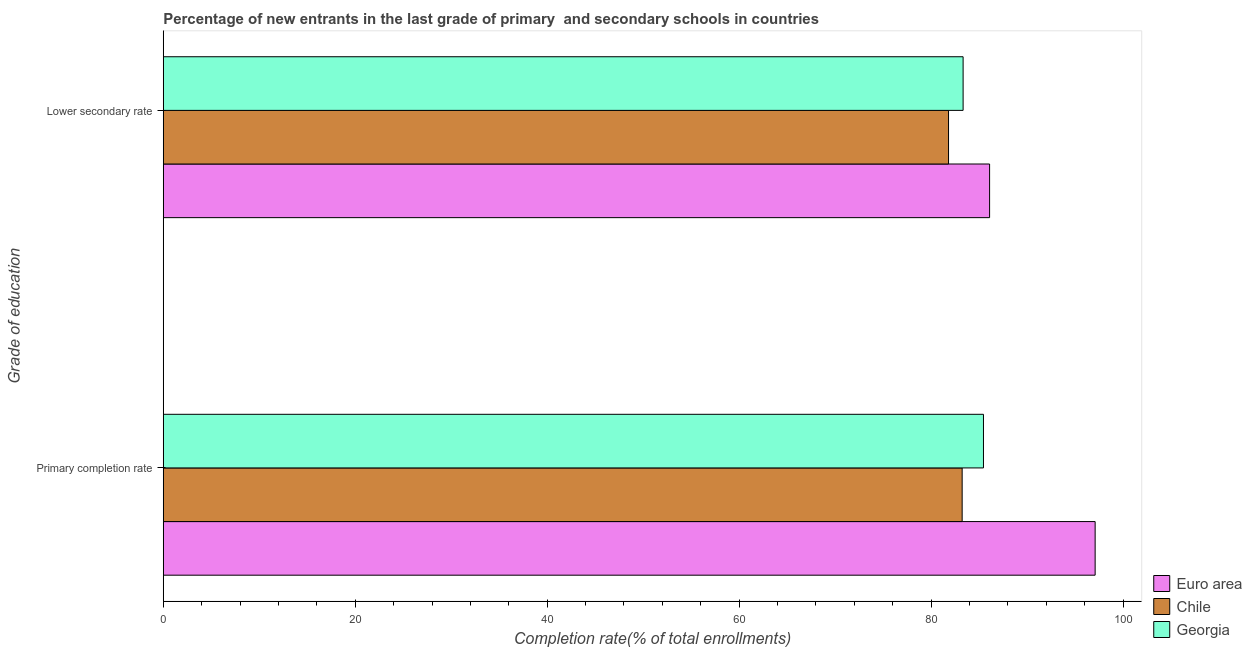How many different coloured bars are there?
Provide a succinct answer. 3. Are the number of bars on each tick of the Y-axis equal?
Provide a succinct answer. Yes. What is the label of the 2nd group of bars from the top?
Offer a very short reply. Primary completion rate. What is the completion rate in secondary schools in Euro area?
Offer a very short reply. 86.09. Across all countries, what is the maximum completion rate in secondary schools?
Your answer should be very brief. 86.09. Across all countries, what is the minimum completion rate in secondary schools?
Make the answer very short. 81.81. In which country was the completion rate in primary schools maximum?
Your answer should be compact. Euro area. In which country was the completion rate in primary schools minimum?
Give a very brief answer. Chile. What is the total completion rate in primary schools in the graph?
Your answer should be compact. 265.78. What is the difference between the completion rate in primary schools in Euro area and that in Georgia?
Provide a short and direct response. 11.63. What is the difference between the completion rate in secondary schools in Georgia and the completion rate in primary schools in Euro area?
Make the answer very short. -13.76. What is the average completion rate in secondary schools per country?
Your response must be concise. 83.75. What is the difference between the completion rate in primary schools and completion rate in secondary schools in Euro area?
Keep it short and to the point. 11. What is the ratio of the completion rate in secondary schools in Georgia to that in Euro area?
Give a very brief answer. 0.97. Is the completion rate in secondary schools in Georgia less than that in Chile?
Give a very brief answer. No. What does the 1st bar from the bottom in Primary completion rate represents?
Offer a very short reply. Euro area. Are all the bars in the graph horizontal?
Ensure brevity in your answer.  Yes. How many countries are there in the graph?
Make the answer very short. 3. Does the graph contain any zero values?
Make the answer very short. No. Does the graph contain grids?
Provide a short and direct response. No. How are the legend labels stacked?
Ensure brevity in your answer.  Vertical. What is the title of the graph?
Ensure brevity in your answer.  Percentage of new entrants in the last grade of primary  and secondary schools in countries. Does "High income: OECD" appear as one of the legend labels in the graph?
Make the answer very short. No. What is the label or title of the X-axis?
Your response must be concise. Completion rate(% of total enrollments). What is the label or title of the Y-axis?
Your answer should be compact. Grade of education. What is the Completion rate(% of total enrollments) of Euro area in Primary completion rate?
Provide a succinct answer. 97.09. What is the Completion rate(% of total enrollments) of Chile in Primary completion rate?
Provide a short and direct response. 83.23. What is the Completion rate(% of total enrollments) of Georgia in Primary completion rate?
Your answer should be very brief. 85.46. What is the Completion rate(% of total enrollments) of Euro area in Lower secondary rate?
Your response must be concise. 86.09. What is the Completion rate(% of total enrollments) in Chile in Lower secondary rate?
Ensure brevity in your answer.  81.81. What is the Completion rate(% of total enrollments) of Georgia in Lower secondary rate?
Your answer should be compact. 83.33. Across all Grade of education, what is the maximum Completion rate(% of total enrollments) of Euro area?
Provide a succinct answer. 97.09. Across all Grade of education, what is the maximum Completion rate(% of total enrollments) of Chile?
Offer a very short reply. 83.23. Across all Grade of education, what is the maximum Completion rate(% of total enrollments) in Georgia?
Your response must be concise. 85.46. Across all Grade of education, what is the minimum Completion rate(% of total enrollments) in Euro area?
Provide a short and direct response. 86.09. Across all Grade of education, what is the minimum Completion rate(% of total enrollments) in Chile?
Your response must be concise. 81.81. Across all Grade of education, what is the minimum Completion rate(% of total enrollments) of Georgia?
Provide a short and direct response. 83.33. What is the total Completion rate(% of total enrollments) of Euro area in the graph?
Make the answer very short. 183.18. What is the total Completion rate(% of total enrollments) in Chile in the graph?
Provide a succinct answer. 165.05. What is the total Completion rate(% of total enrollments) in Georgia in the graph?
Provide a succinct answer. 168.79. What is the difference between the Completion rate(% of total enrollments) of Euro area in Primary completion rate and that in Lower secondary rate?
Your answer should be compact. 11. What is the difference between the Completion rate(% of total enrollments) of Chile in Primary completion rate and that in Lower secondary rate?
Your response must be concise. 1.42. What is the difference between the Completion rate(% of total enrollments) of Georgia in Primary completion rate and that in Lower secondary rate?
Keep it short and to the point. 2.12. What is the difference between the Completion rate(% of total enrollments) in Euro area in Primary completion rate and the Completion rate(% of total enrollments) in Chile in Lower secondary rate?
Your response must be concise. 15.27. What is the difference between the Completion rate(% of total enrollments) in Euro area in Primary completion rate and the Completion rate(% of total enrollments) in Georgia in Lower secondary rate?
Offer a very short reply. 13.76. What is the difference between the Completion rate(% of total enrollments) of Chile in Primary completion rate and the Completion rate(% of total enrollments) of Georgia in Lower secondary rate?
Provide a short and direct response. -0.1. What is the average Completion rate(% of total enrollments) of Euro area per Grade of education?
Make the answer very short. 91.59. What is the average Completion rate(% of total enrollments) of Chile per Grade of education?
Your answer should be very brief. 82.52. What is the average Completion rate(% of total enrollments) in Georgia per Grade of education?
Provide a succinct answer. 84.39. What is the difference between the Completion rate(% of total enrollments) in Euro area and Completion rate(% of total enrollments) in Chile in Primary completion rate?
Your answer should be compact. 13.86. What is the difference between the Completion rate(% of total enrollments) in Euro area and Completion rate(% of total enrollments) in Georgia in Primary completion rate?
Your response must be concise. 11.63. What is the difference between the Completion rate(% of total enrollments) of Chile and Completion rate(% of total enrollments) of Georgia in Primary completion rate?
Your answer should be compact. -2.22. What is the difference between the Completion rate(% of total enrollments) of Euro area and Completion rate(% of total enrollments) of Chile in Lower secondary rate?
Give a very brief answer. 4.28. What is the difference between the Completion rate(% of total enrollments) in Euro area and Completion rate(% of total enrollments) in Georgia in Lower secondary rate?
Your answer should be very brief. 2.76. What is the difference between the Completion rate(% of total enrollments) of Chile and Completion rate(% of total enrollments) of Georgia in Lower secondary rate?
Your answer should be compact. -1.52. What is the ratio of the Completion rate(% of total enrollments) in Euro area in Primary completion rate to that in Lower secondary rate?
Your response must be concise. 1.13. What is the ratio of the Completion rate(% of total enrollments) of Chile in Primary completion rate to that in Lower secondary rate?
Your answer should be compact. 1.02. What is the ratio of the Completion rate(% of total enrollments) of Georgia in Primary completion rate to that in Lower secondary rate?
Your response must be concise. 1.03. What is the difference between the highest and the second highest Completion rate(% of total enrollments) in Euro area?
Your answer should be very brief. 11. What is the difference between the highest and the second highest Completion rate(% of total enrollments) of Chile?
Give a very brief answer. 1.42. What is the difference between the highest and the second highest Completion rate(% of total enrollments) of Georgia?
Provide a short and direct response. 2.12. What is the difference between the highest and the lowest Completion rate(% of total enrollments) in Euro area?
Ensure brevity in your answer.  11. What is the difference between the highest and the lowest Completion rate(% of total enrollments) in Chile?
Provide a short and direct response. 1.42. What is the difference between the highest and the lowest Completion rate(% of total enrollments) of Georgia?
Offer a terse response. 2.12. 